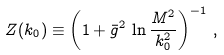Convert formula to latex. <formula><loc_0><loc_0><loc_500><loc_500>Z ( k _ { 0 } ) \equiv \left ( 1 + \bar { g } ^ { 2 } \, \ln \frac { M ^ { 2 } } { k _ { 0 } ^ { 2 } } \right ) ^ { - 1 } \, ,</formula> 